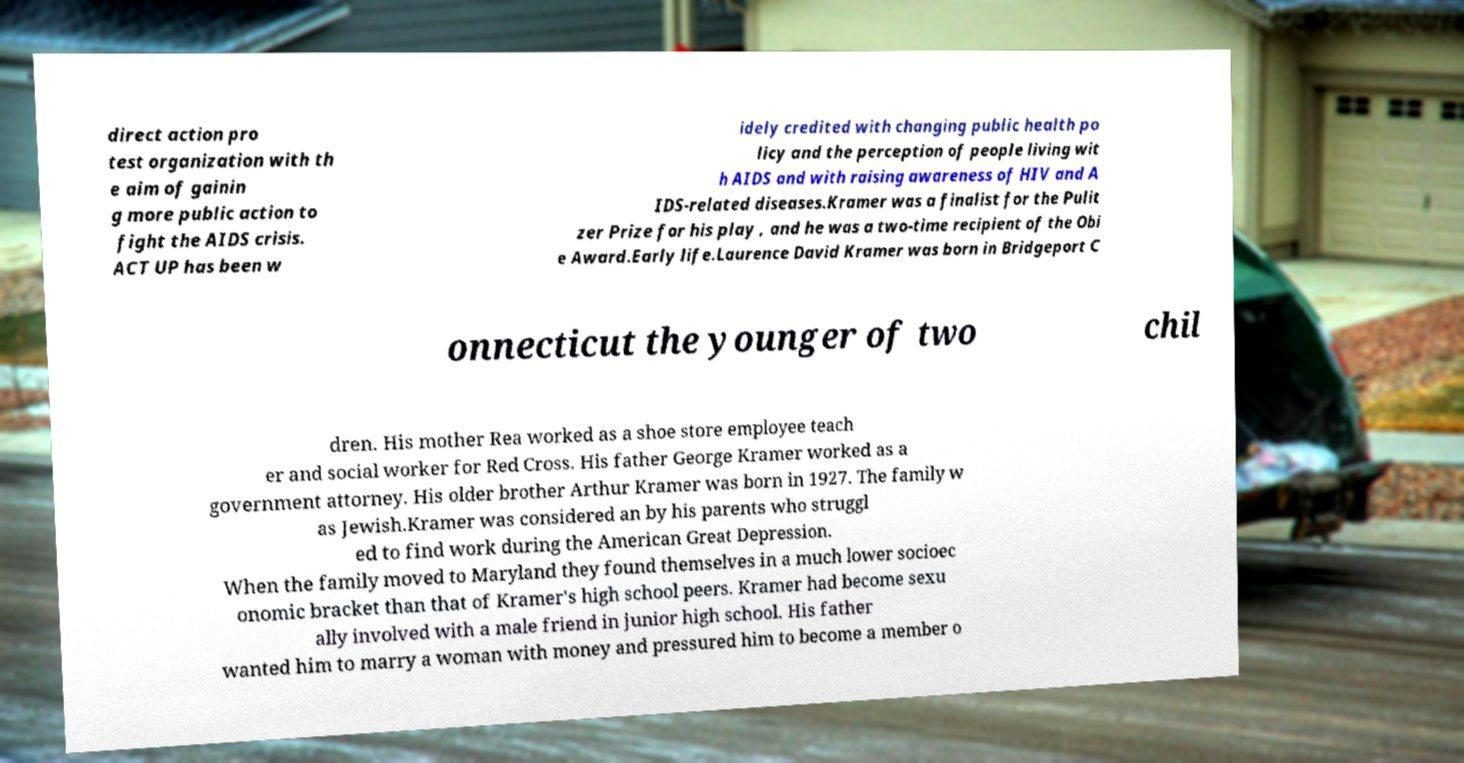Please read and relay the text visible in this image. What does it say? direct action pro test organization with th e aim of gainin g more public action to fight the AIDS crisis. ACT UP has been w idely credited with changing public health po licy and the perception of people living wit h AIDS and with raising awareness of HIV and A IDS-related diseases.Kramer was a finalist for the Pulit zer Prize for his play , and he was a two-time recipient of the Obi e Award.Early life.Laurence David Kramer was born in Bridgeport C onnecticut the younger of two chil dren. His mother Rea worked as a shoe store employee teach er and social worker for Red Cross. His father George Kramer worked as a government attorney. His older brother Arthur Kramer was born in 1927. The family w as Jewish.Kramer was considered an by his parents who struggl ed to find work during the American Great Depression. When the family moved to Maryland they found themselves in a much lower socioec onomic bracket than that of Kramer's high school peers. Kramer had become sexu ally involved with a male friend in junior high school. His father wanted him to marry a woman with money and pressured him to become a member o 